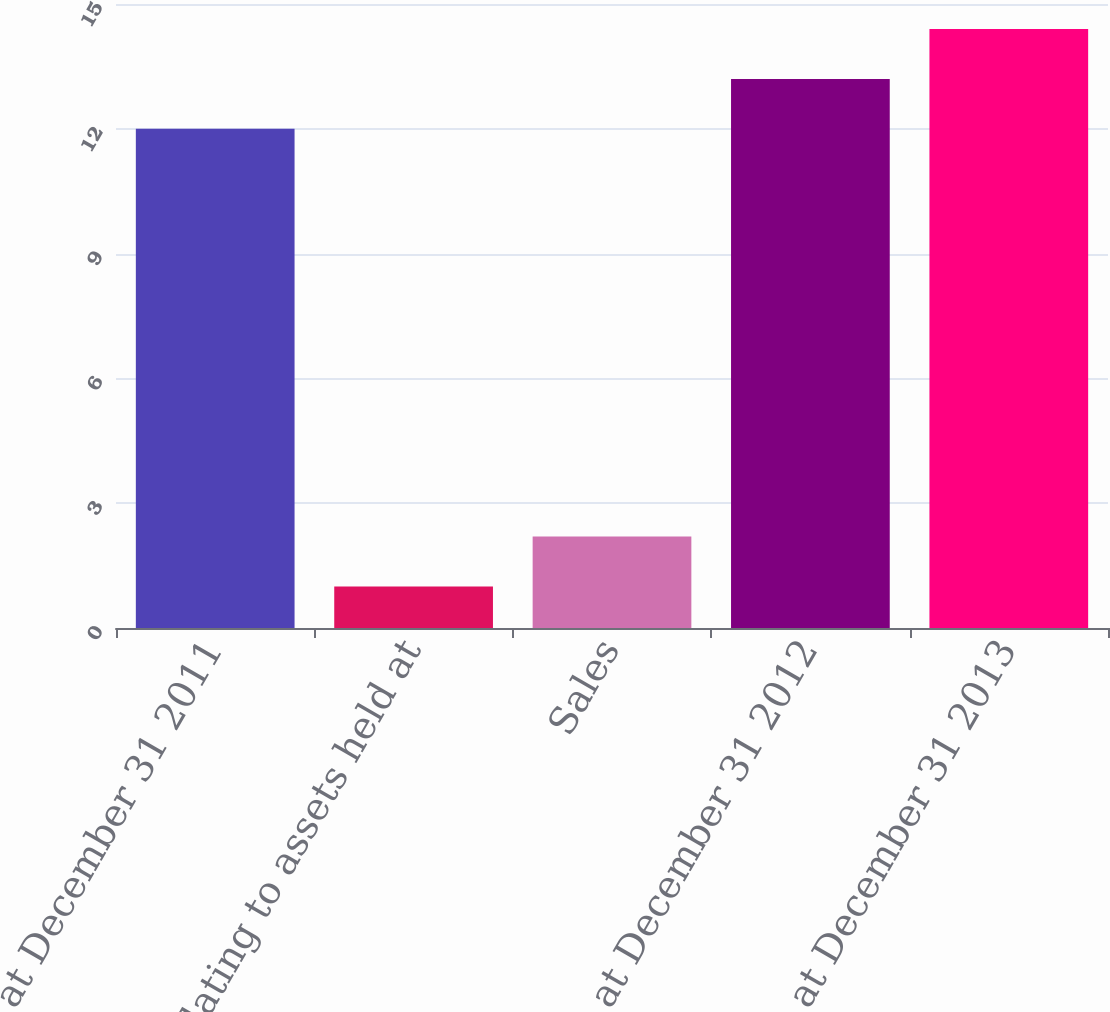Convert chart. <chart><loc_0><loc_0><loc_500><loc_500><bar_chart><fcel>Balance at December 31 2011<fcel>Relating to assets held at<fcel>Sales<fcel>Balance at December 31 2012<fcel>Balance at December 31 2013<nl><fcel>12<fcel>1<fcel>2.2<fcel>13.2<fcel>14.4<nl></chart> 